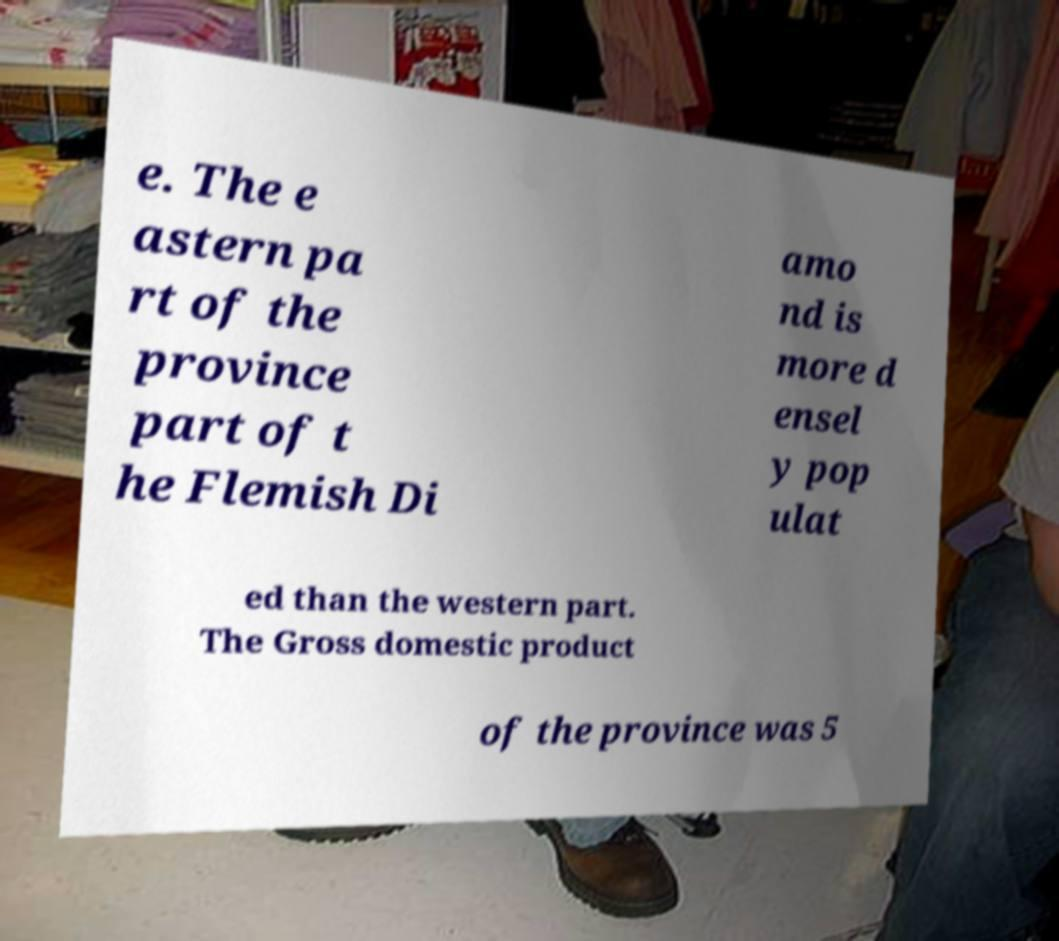Could you assist in decoding the text presented in this image and type it out clearly? e. The e astern pa rt of the province part of t he Flemish Di amo nd is more d ensel y pop ulat ed than the western part. The Gross domestic product of the province was 5 